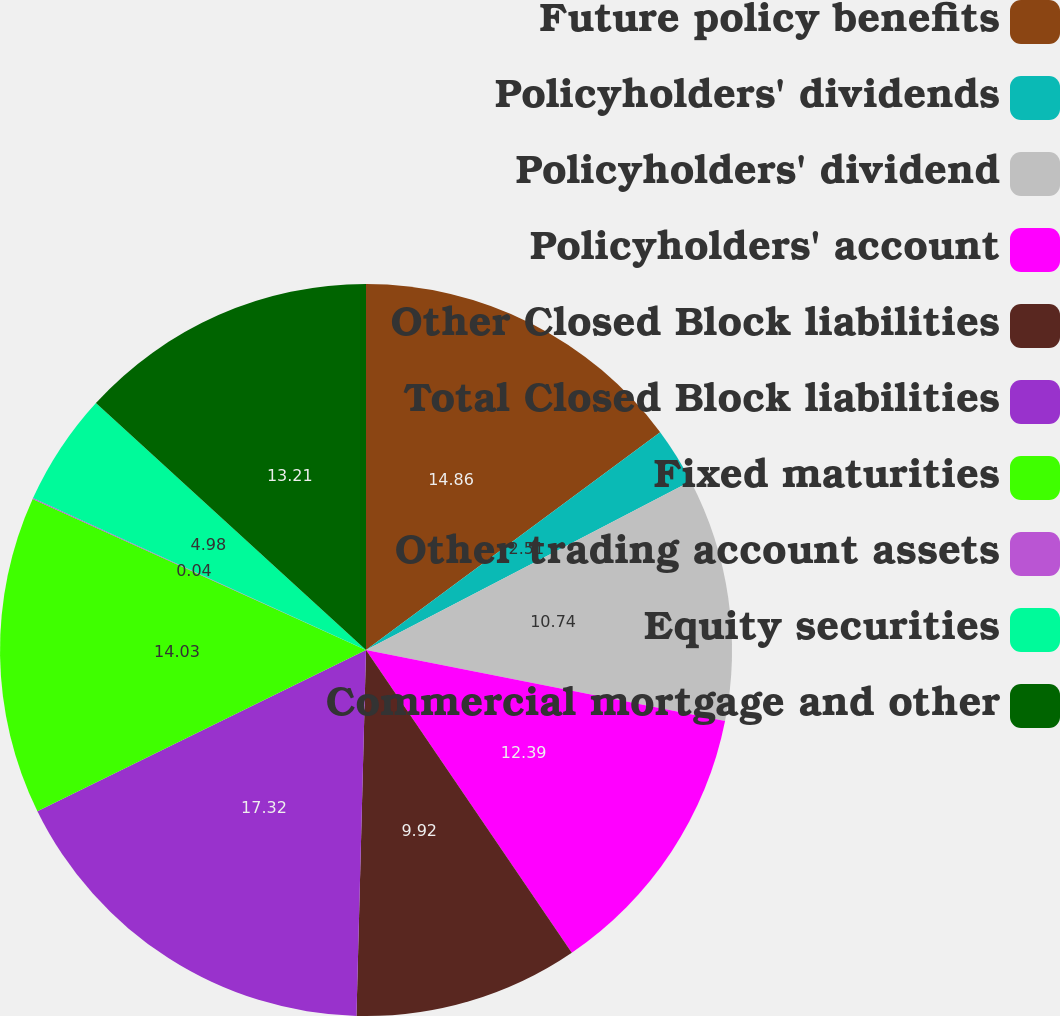<chart> <loc_0><loc_0><loc_500><loc_500><pie_chart><fcel>Future policy benefits<fcel>Policyholders' dividends<fcel>Policyholders' dividend<fcel>Policyholders' account<fcel>Other Closed Block liabilities<fcel>Total Closed Block liabilities<fcel>Fixed maturities<fcel>Other trading account assets<fcel>Equity securities<fcel>Commercial mortgage and other<nl><fcel>14.86%<fcel>2.51%<fcel>10.74%<fcel>12.39%<fcel>9.92%<fcel>17.33%<fcel>14.03%<fcel>0.04%<fcel>4.98%<fcel>13.21%<nl></chart> 